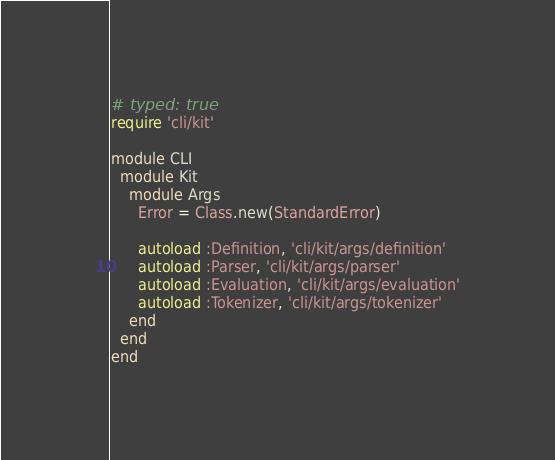<code> <loc_0><loc_0><loc_500><loc_500><_Ruby_># typed: true
require 'cli/kit'

module CLI
  module Kit
    module Args
      Error = Class.new(StandardError)

      autoload :Definition, 'cli/kit/args/definition'
      autoload :Parser, 'cli/kit/args/parser'
      autoload :Evaluation, 'cli/kit/args/evaluation'
      autoload :Tokenizer, 'cli/kit/args/tokenizer'
    end
  end
end
</code> 